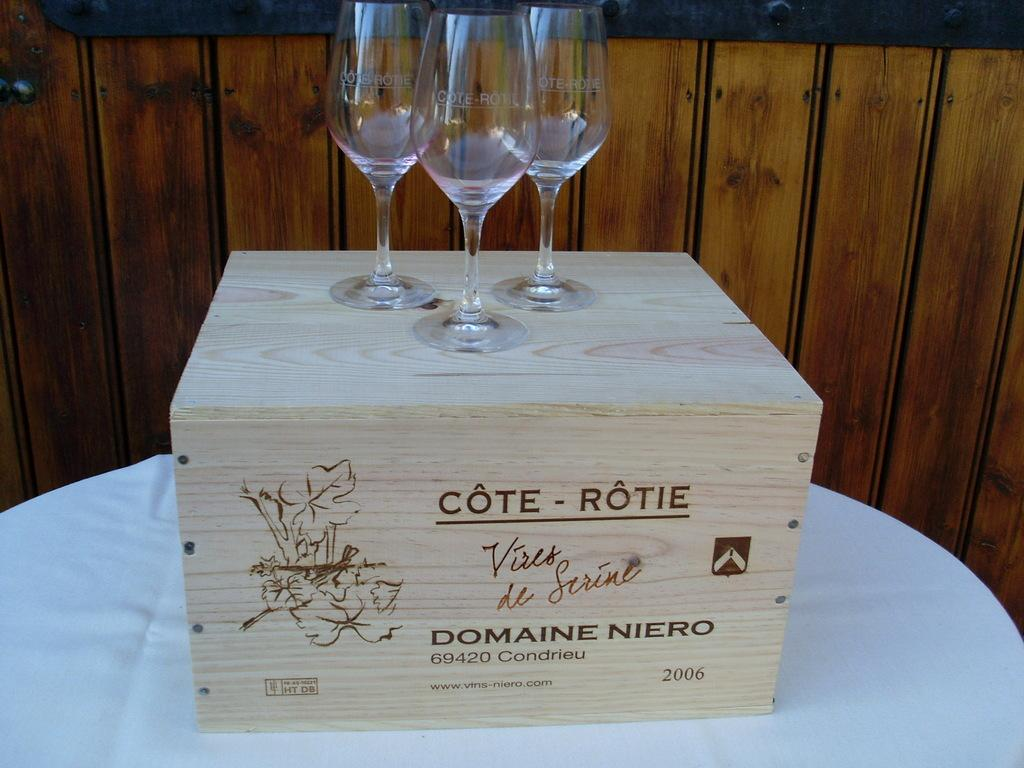What is the main color of the surface in the image? The main color of the surface in the image is white. What object is placed on the white surface? There is a wooden box on the white surface. What can be seen on the wooden box? The wooden box has text and drawing on it. How many glasses are on the wooden box? There are three glasses on the wooden box. What is visible in the background of the image? There is a wooden wall in the background of the image. What type of spark can be seen coming from the pencil in the image? There is no pencil present in the image, so no spark can be seen coming from it. 